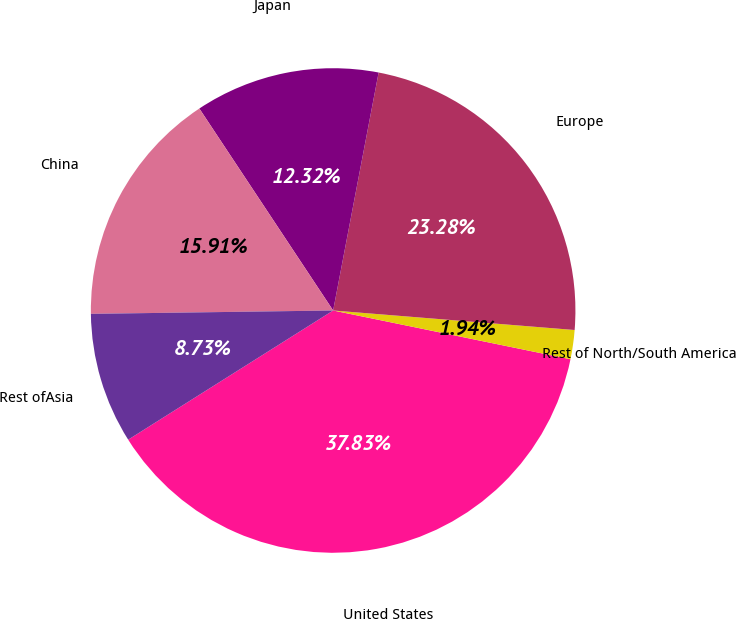<chart> <loc_0><loc_0><loc_500><loc_500><pie_chart><fcel>United States<fcel>Rest of North/South America<fcel>Europe<fcel>Japan<fcel>China<fcel>Rest ofAsia<nl><fcel>37.83%<fcel>1.94%<fcel>23.28%<fcel>12.32%<fcel>15.91%<fcel>8.73%<nl></chart> 